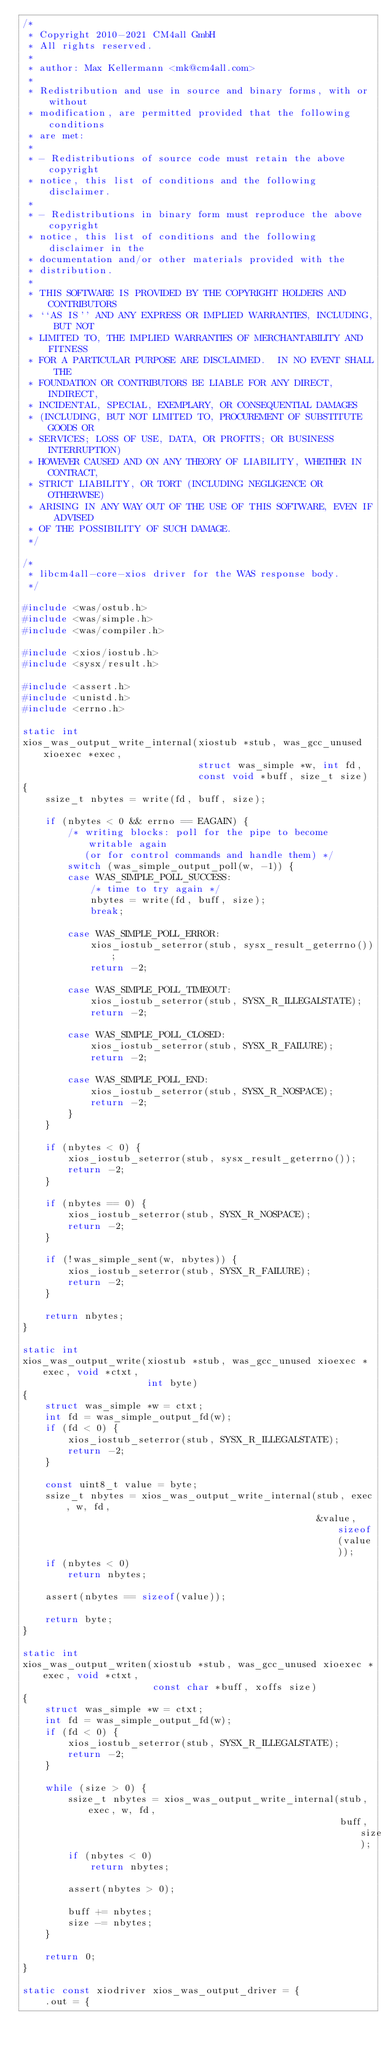Convert code to text. <code><loc_0><loc_0><loc_500><loc_500><_C_>/*
 * Copyright 2010-2021 CM4all GmbH
 * All rights reserved.
 *
 * author: Max Kellermann <mk@cm4all.com>
 *
 * Redistribution and use in source and binary forms, with or without
 * modification, are permitted provided that the following conditions
 * are met:
 *
 * - Redistributions of source code must retain the above copyright
 * notice, this list of conditions and the following disclaimer.
 *
 * - Redistributions in binary form must reproduce the above copyright
 * notice, this list of conditions and the following disclaimer in the
 * documentation and/or other materials provided with the
 * distribution.
 *
 * THIS SOFTWARE IS PROVIDED BY THE COPYRIGHT HOLDERS AND CONTRIBUTORS
 * ``AS IS'' AND ANY EXPRESS OR IMPLIED WARRANTIES, INCLUDING, BUT NOT
 * LIMITED TO, THE IMPLIED WARRANTIES OF MERCHANTABILITY AND FITNESS
 * FOR A PARTICULAR PURPOSE ARE DISCLAIMED.  IN NO EVENT SHALL THE
 * FOUNDATION OR CONTRIBUTORS BE LIABLE FOR ANY DIRECT, INDIRECT,
 * INCIDENTAL, SPECIAL, EXEMPLARY, OR CONSEQUENTIAL DAMAGES
 * (INCLUDING, BUT NOT LIMITED TO, PROCUREMENT OF SUBSTITUTE GOODS OR
 * SERVICES; LOSS OF USE, DATA, OR PROFITS; OR BUSINESS INTERRUPTION)
 * HOWEVER CAUSED AND ON ANY THEORY OF LIABILITY, WHETHER IN CONTRACT,
 * STRICT LIABILITY, OR TORT (INCLUDING NEGLIGENCE OR OTHERWISE)
 * ARISING IN ANY WAY OUT OF THE USE OF THIS SOFTWARE, EVEN IF ADVISED
 * OF THE POSSIBILITY OF SUCH DAMAGE.
 */

/*
 * libcm4all-core-xios driver for the WAS response body.
 */

#include <was/ostub.h>
#include <was/simple.h>
#include <was/compiler.h>

#include <xios/iostub.h>
#include <sysx/result.h>

#include <assert.h>
#include <unistd.h>
#include <errno.h>

static int
xios_was_output_write_internal(xiostub *stub, was_gcc_unused xioexec *exec,
                               struct was_simple *w, int fd,
                               const void *buff, size_t size)
{
    ssize_t nbytes = write(fd, buff, size);

    if (nbytes < 0 && errno == EAGAIN) {
        /* writing blocks: poll for the pipe to become writable again
           (or for control commands and handle them) */
        switch (was_simple_output_poll(w, -1)) {
        case WAS_SIMPLE_POLL_SUCCESS:
            /* time to try again */
            nbytes = write(fd, buff, size);
            break;

        case WAS_SIMPLE_POLL_ERROR:
            xios_iostub_seterror(stub, sysx_result_geterrno());
            return -2;

        case WAS_SIMPLE_POLL_TIMEOUT:
            xios_iostub_seterror(stub, SYSX_R_ILLEGALSTATE);
            return -2;

        case WAS_SIMPLE_POLL_CLOSED:
            xios_iostub_seterror(stub, SYSX_R_FAILURE);
            return -2;

        case WAS_SIMPLE_POLL_END:
            xios_iostub_seterror(stub, SYSX_R_NOSPACE);
            return -2;
        }
    }

    if (nbytes < 0) {
        xios_iostub_seterror(stub, sysx_result_geterrno());
        return -2;
    }

    if (nbytes == 0) {
        xios_iostub_seterror(stub, SYSX_R_NOSPACE);
        return -2;
    }

    if (!was_simple_sent(w, nbytes)) {
        xios_iostub_seterror(stub, SYSX_R_FAILURE);
        return -2;
    }

    return nbytes;
}

static int
xios_was_output_write(xiostub *stub, was_gcc_unused xioexec *exec, void *ctxt,
                      int byte)
{
    struct was_simple *w = ctxt;
    int fd = was_simple_output_fd(w);
    if (fd < 0) {
        xios_iostub_seterror(stub, SYSX_R_ILLEGALSTATE);
        return -2;
    }

    const uint8_t value = byte;
    ssize_t nbytes = xios_was_output_write_internal(stub, exec, w, fd,
                                                    &value, sizeof(value));
    if (nbytes < 0)
        return nbytes;

    assert(nbytes == sizeof(value));

    return byte;
}

static int
xios_was_output_writen(xiostub *stub, was_gcc_unused xioexec *exec, void *ctxt,
                       const char *buff, xoffs size)
{
    struct was_simple *w = ctxt;
    int fd = was_simple_output_fd(w);
    if (fd < 0) {
        xios_iostub_seterror(stub, SYSX_R_ILLEGALSTATE);
        return -2;
    }

    while (size > 0) {
        ssize_t nbytes = xios_was_output_write_internal(stub, exec, w, fd,
                                                        buff, size);
        if (nbytes < 0)
            return nbytes;

        assert(nbytes > 0);

        buff += nbytes;
        size -= nbytes;
    }

    return 0;
}

static const xiodriver xios_was_output_driver = {
    .out = {</code> 